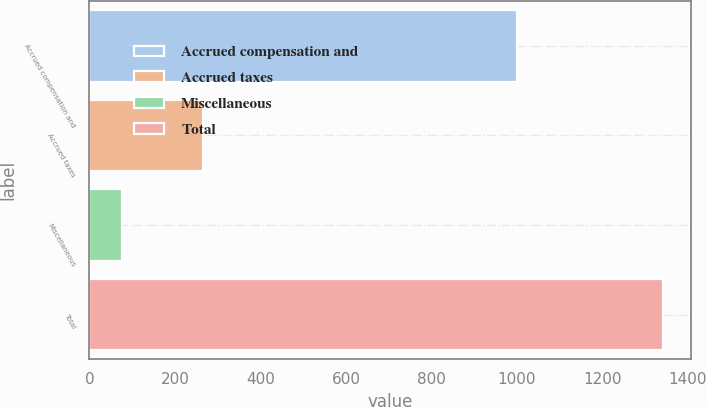Convert chart to OTSL. <chart><loc_0><loc_0><loc_500><loc_500><bar_chart><fcel>Accrued compensation and<fcel>Accrued taxes<fcel>Miscellaneous<fcel>Total<nl><fcel>999.4<fcel>265.3<fcel>76.3<fcel>1341<nl></chart> 